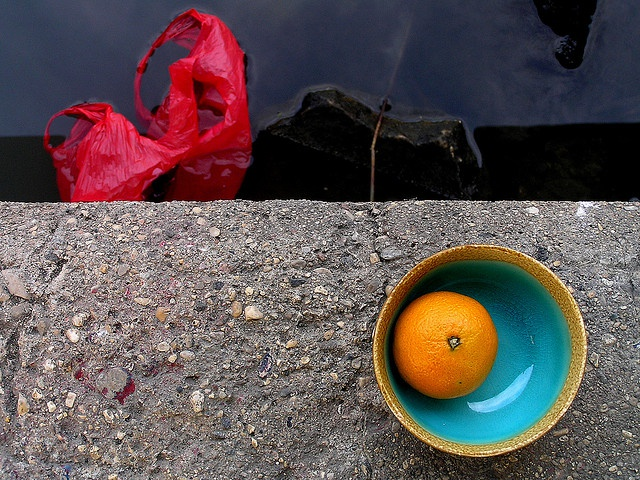Describe the objects in this image and their specific colors. I can see bowl in darkblue, black, olive, and teal tones and orange in darkblue, red, orange, brown, and maroon tones in this image. 